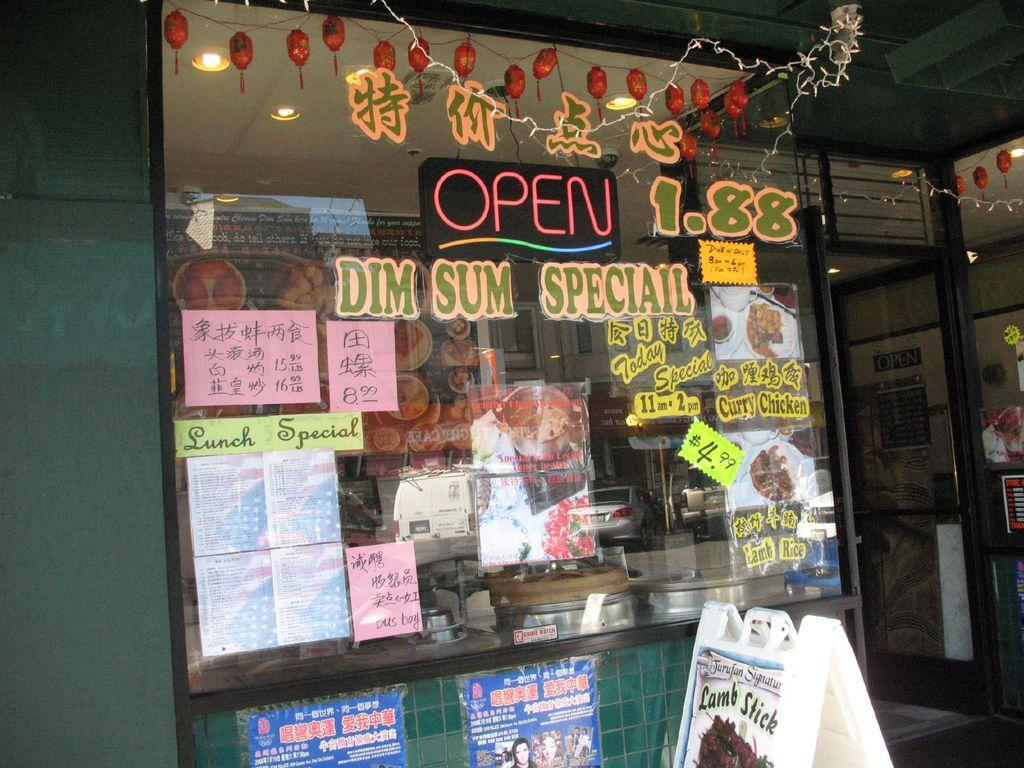What is on the glass in the image? There are posts on the glass in the image. What other items can be seen in the image? There are decorative objects, lights, a door, a board, and a wall in the image. What is visible in the reflection on the glass? The reflection of cars, poles, and a building is visible on the glass. Can you tell me how many robins are sitting on the hydrant in the image? There are no robins or hydrants present in the image. What type of soda is being served in the image? There is no soda present in the image. 